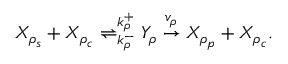<formula> <loc_0><loc_0><loc_500><loc_500>\begin{array} { r } { X _ { \rho _ { s } } + X _ { \rho _ { c } } \rightleftharpoons _ { k _ { \rho } ^ { - } } ^ { k _ { \rho } ^ { + } } Y _ { \rho } \overset { v _ { \rho } } { \to } X _ { \rho _ { p } } + X _ { \rho _ { c } } . } \end{array}</formula> 